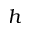<formula> <loc_0><loc_0><loc_500><loc_500>h</formula> 